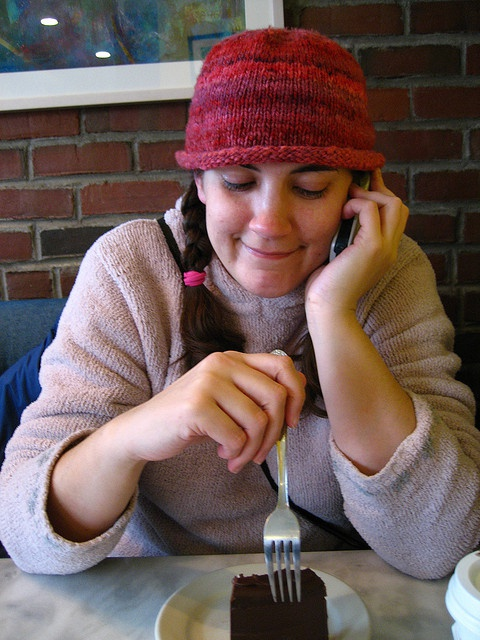Describe the objects in this image and their specific colors. I can see people in darkgreen, maroon, black, gray, and brown tones, dining table in darkgreen, gray, and darkgray tones, cake in darkgreen, black, gray, maroon, and darkgray tones, fork in darkgreen, darkgray, gray, tan, and black tones, and chair in darkgreen, blue, darkblue, and black tones in this image. 